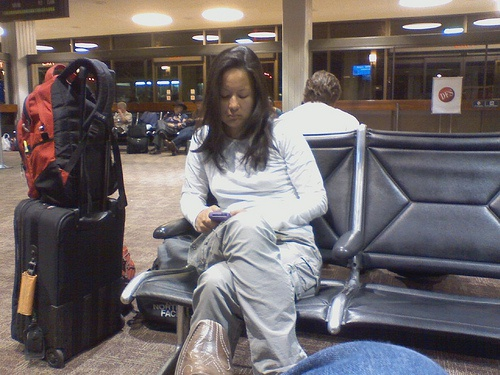Describe the objects in this image and their specific colors. I can see bench in black and gray tones, people in black, lightgray, darkgray, and gray tones, chair in black and gray tones, suitcase in black, gray, and tan tones, and backpack in black, maroon, gray, and brown tones in this image. 